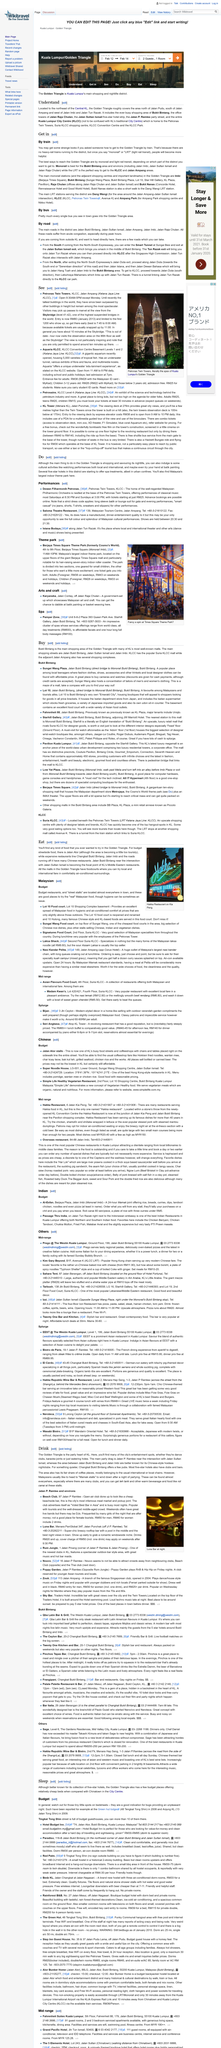Specify some key components in this picture. The Hakka restaurant has been in the restaurant business for more than 40 years. The Malaysian Philharmonic Orchestra offers performances that are available at a starting price of RM25. It is recommended to take the monorail as the most convenient mode of transportation to reach the Bukit Bintang area. Both Prego @ The Westin Kuala Lumpur and Kim Gary Beyond are considered to be in the mid-range category. At Mamak stalls, a wide variety of drinks are available to customers, including coffee, teh tark, and rot canai. 